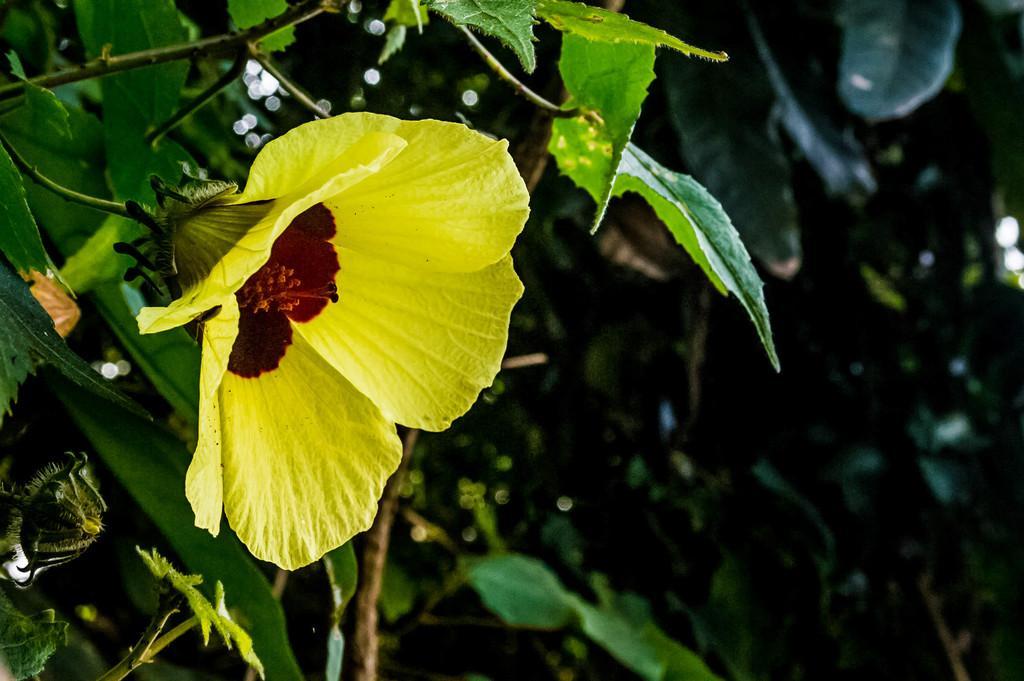Could you give a brief overview of what you see in this image? In this image there is a plant having a flower and a bud. Background there are few plants having leaves. 